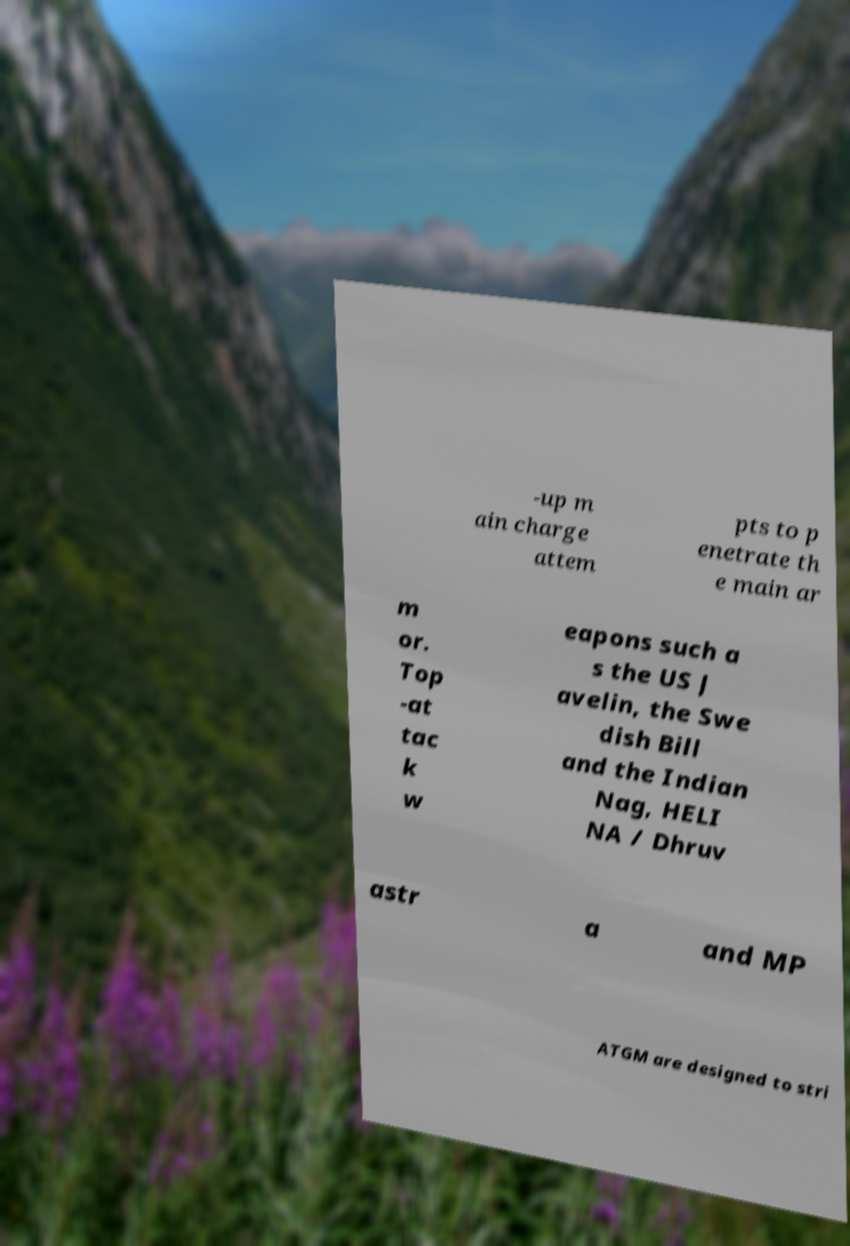Can you accurately transcribe the text from the provided image for me? -up m ain charge attem pts to p enetrate th e main ar m or. Top -at tac k w eapons such a s the US J avelin, the Swe dish Bill and the Indian Nag, HELI NA / Dhruv astr a and MP ATGM are designed to stri 